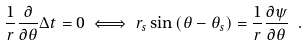Convert formula to latex. <formula><loc_0><loc_0><loc_500><loc_500>\frac { 1 } { r } \frac { \partial } { \partial \theta } \Delta t = 0 \iff r _ { s } \sin { ( \theta - \theta _ { s } ) } = \frac { 1 } { r } \frac { \partial \psi } { \partial \theta } \ .</formula> 